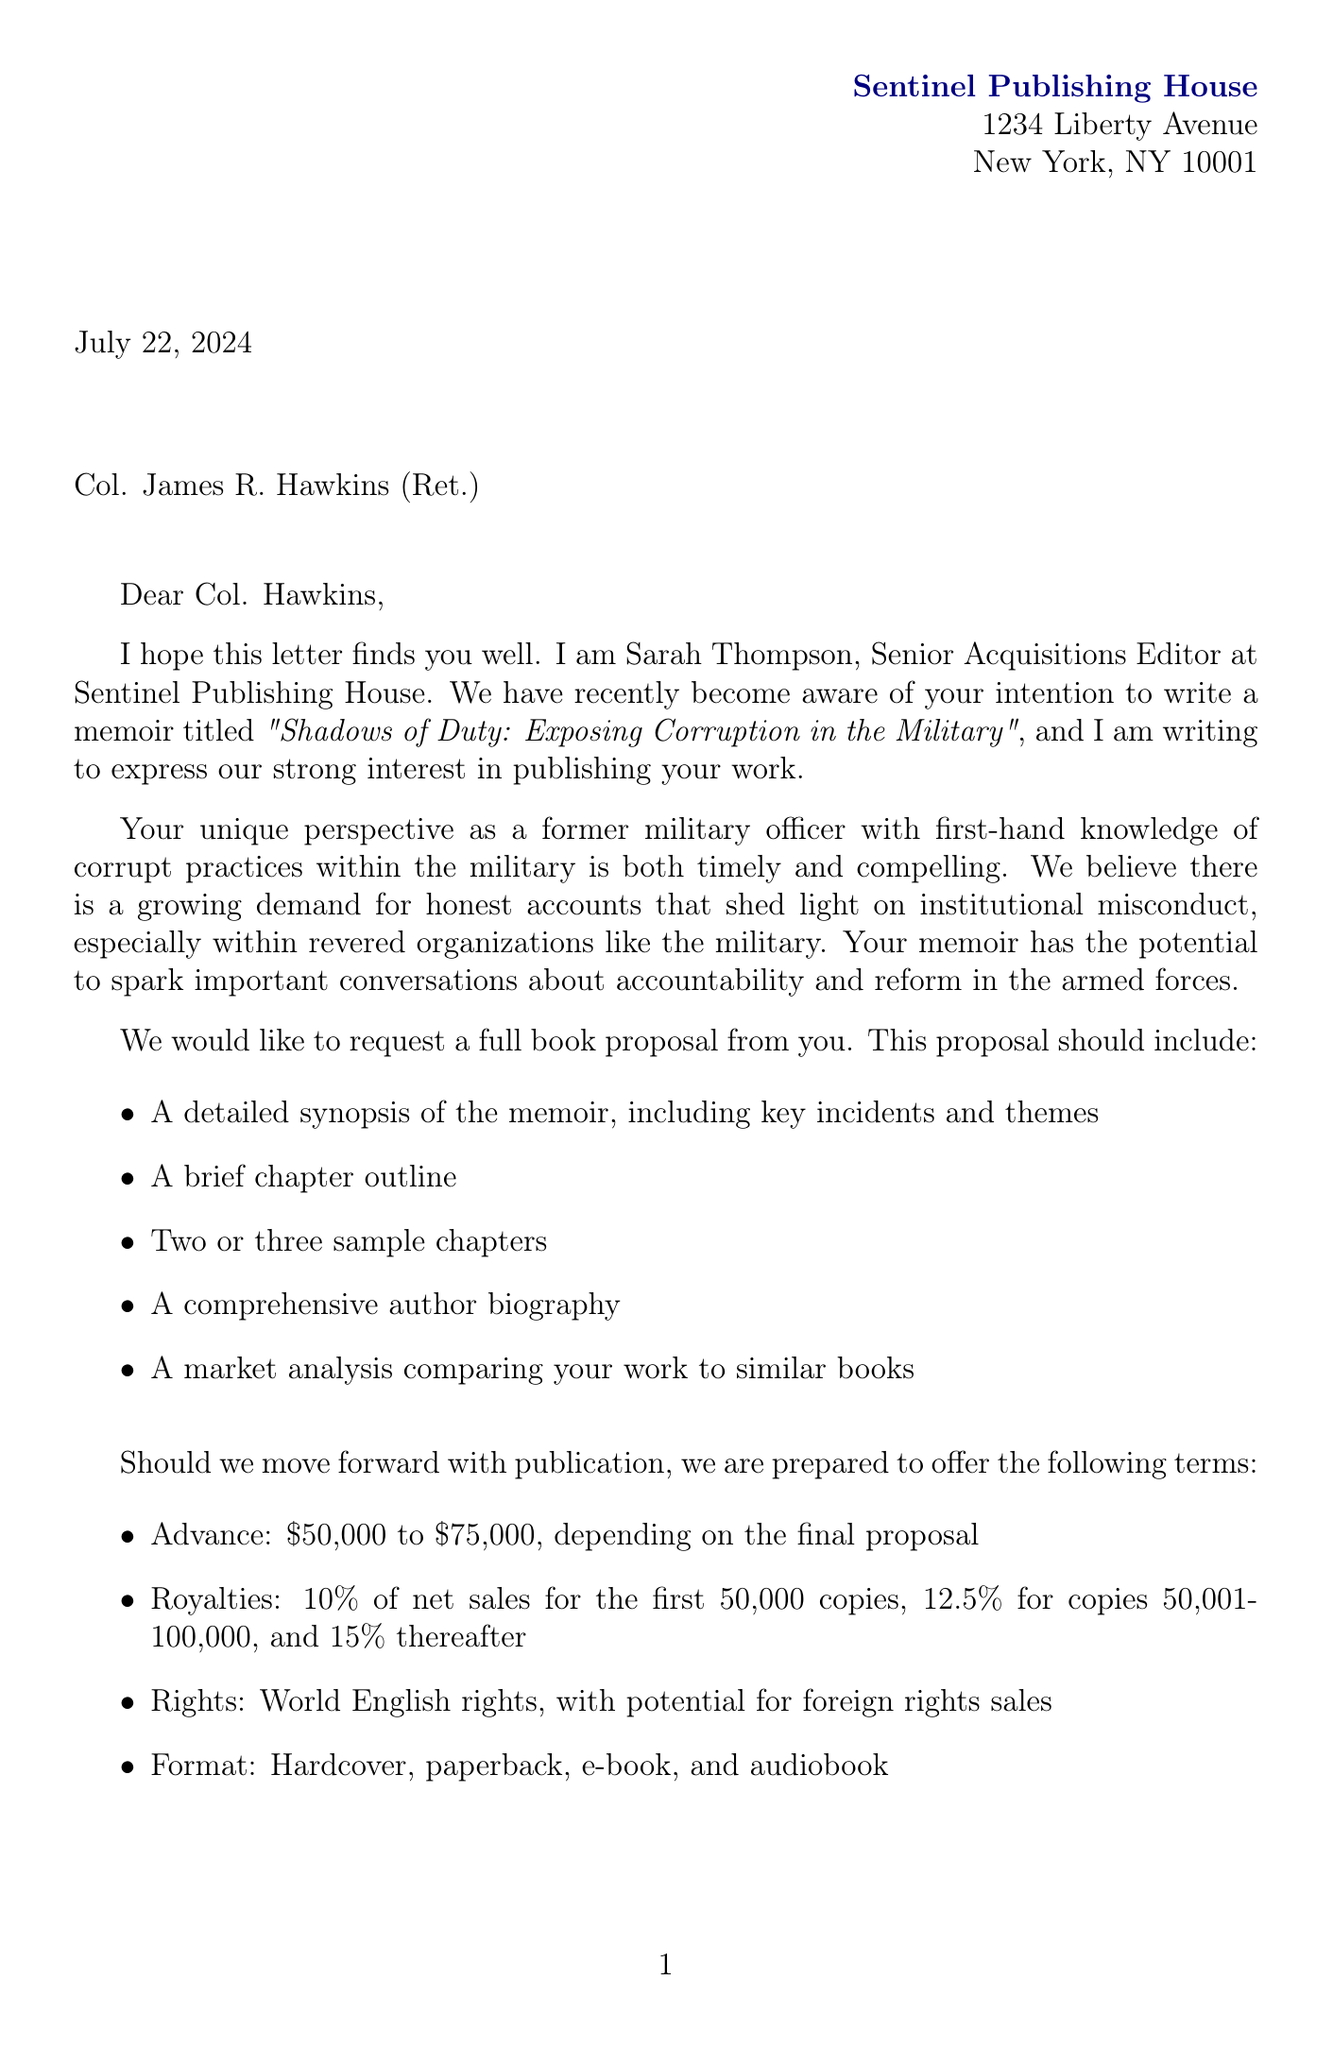What is the name of the publisher? The document explicitly mentions the name of the publisher as Sentinel Publishing House.
Answer: Sentinel Publishing House What is the working title of the memoir? The working title provided in the document is indicated clearly in the memoir details section.
Answer: Shadows of Duty: Exposing Corruption in the Military Who is the Senior Acquisitions Editor? The letter states the name and position of the editor who expressed interest in the memoir.
Answer: Sarah Thompson What is the advance range offered for the memoir? The document specifies the advance amount that the publisher is willing to offer for the book proposal.
Answer: $50,000 to $75,000 What is the proposed manuscript deadline? The document states the timeline regarding when the manuscript needs to be submitted after signing the contract.
Answer: 9 months after contract signing Why is the memoir considered timely? The letter explains the growing demand for honest accounts of misconduct, making the memoir particularly significant at this time.
Answer: It sheds light on institutional misconduct What are the royalties for copies sold after 100,000? The document specifies the percentage of royalties that the author will receive after selling a certain number of copies.
Answer: 15% What type of rights will be granted for the memoir? The letter indicates the rights that will be included in the publication agreement.
Answer: World English rights When is the tentative publication date? The document mentions a specific timeframe when the memoir is expected to be published if the proposal is accepted.
Answer: Fall 2024 What importance does the editor's experience have for the proposal? The letter notes the editor's background, suggesting that it enhances the credibility and interest in the memoir project.
Answer: Edited bestselling military memoirs 